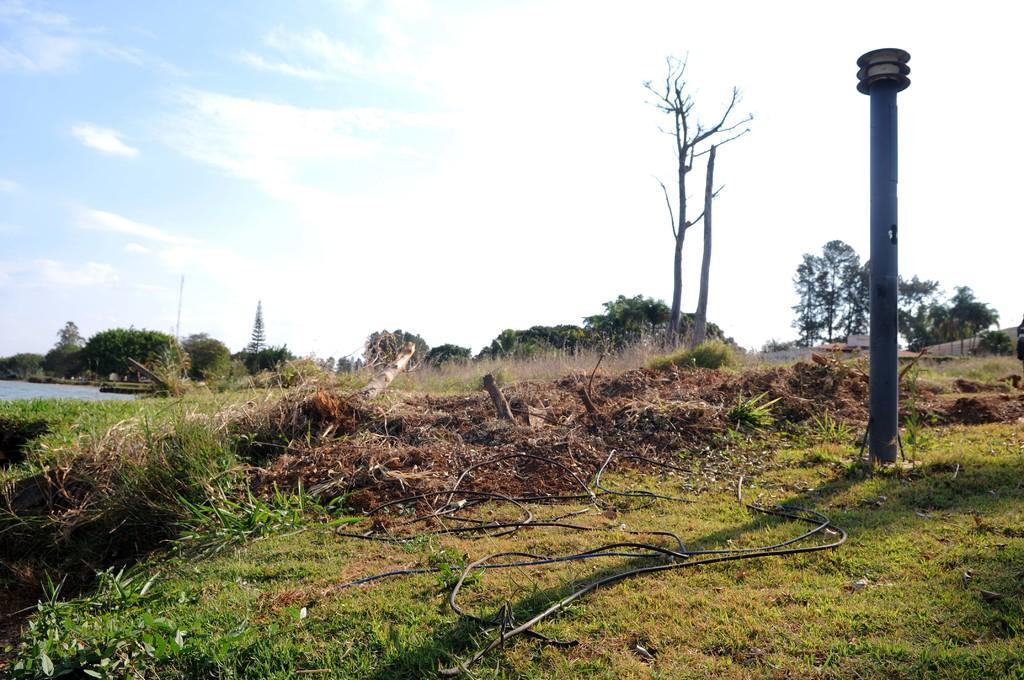Describe this image in one or two sentences. There is a pole, which is attached to the ground, which is having grass on it. There are cable. In the background, there is a water, there are trees and clouds in the blue sky. 